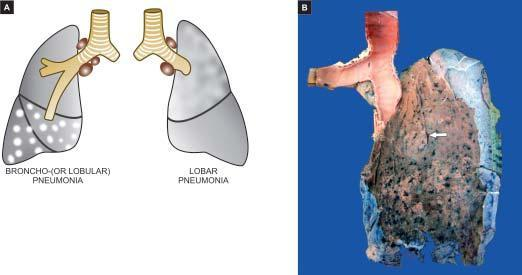does nuclei show serofibrinous exudate?
Answer the question using a single word or phrase. No 